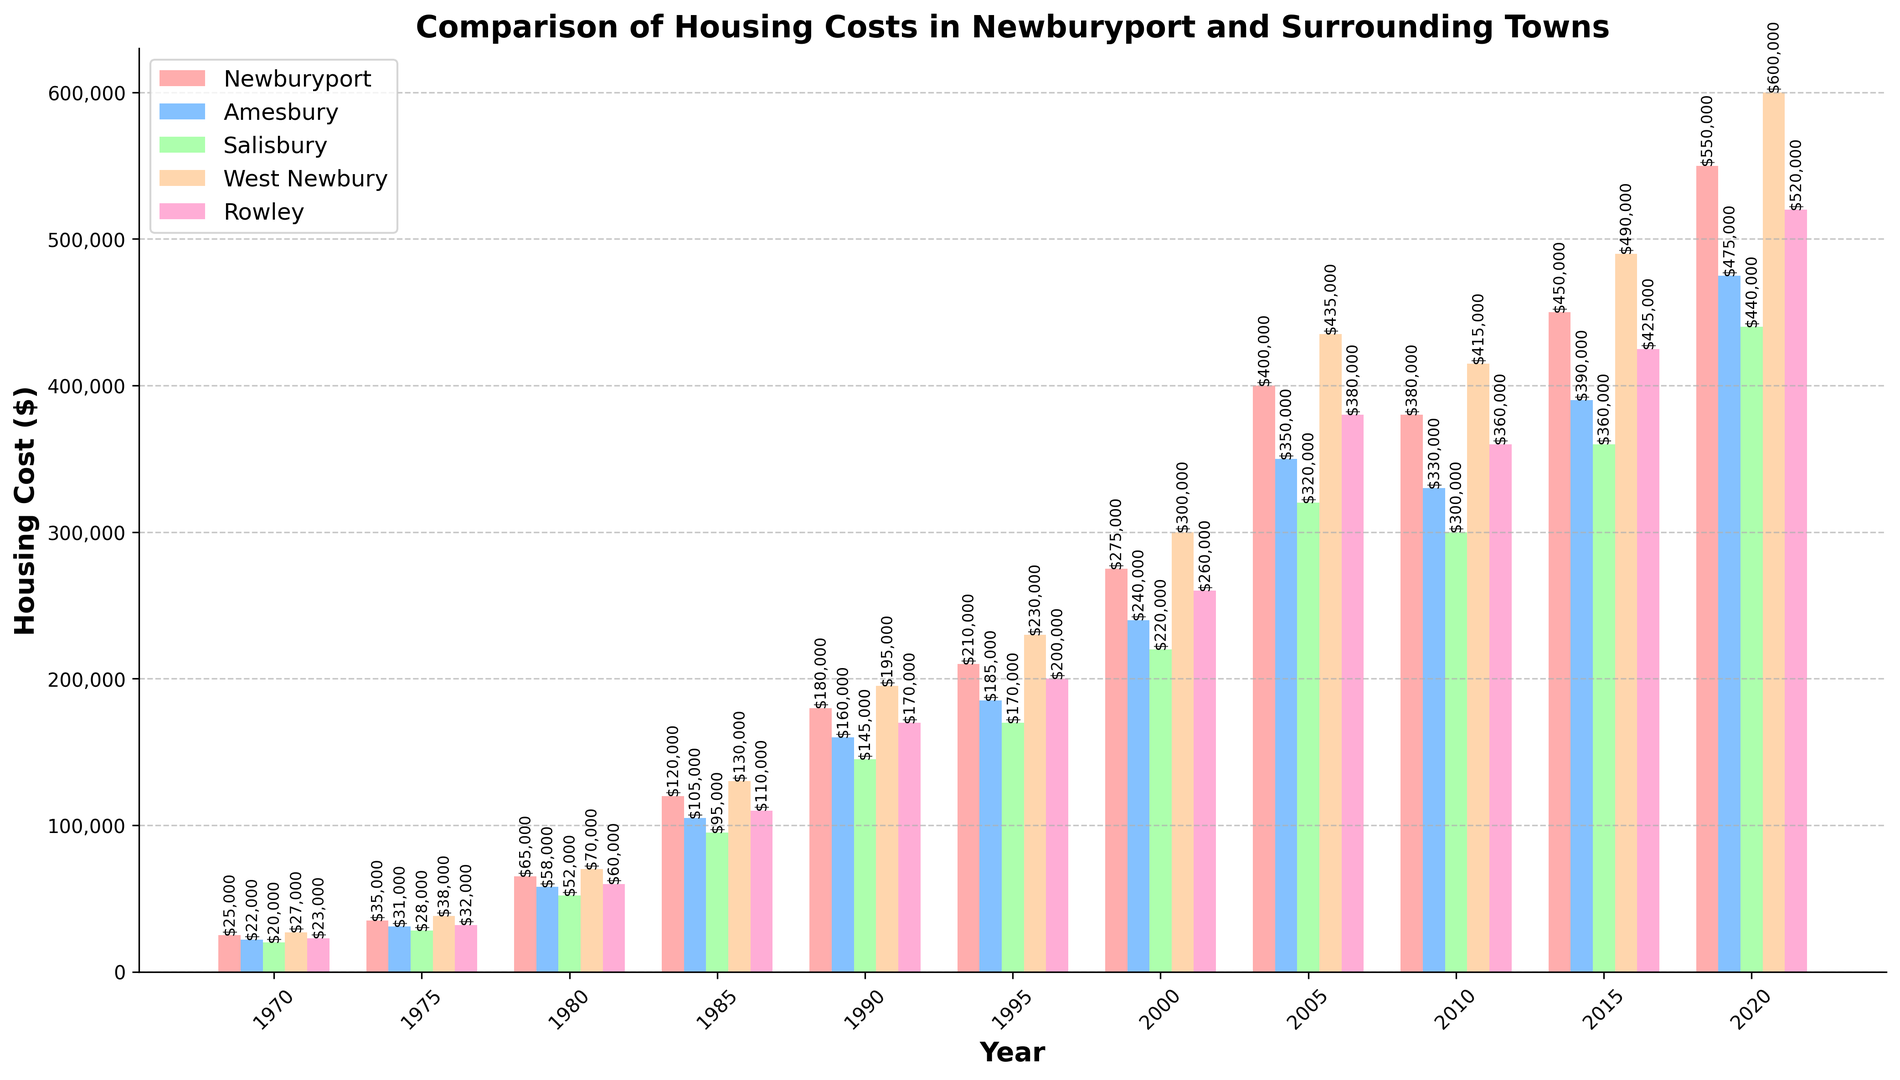What is the trend in housing costs in Newburyport from 1970 to 2020? The trend can be observed by looking at the height of the bars representing Newburyport across the years on the x-axis. From 1970 to 2020, the housing costs in Newburyport show an increasing trend, as the height of the bars continuously rises over the years.
Answer: Increasing How did housing costs in West Newbury change from 2005 to 2010? By comparing the height of the bars for West Newbury in 2005 and 2010, we can see that the housing cost in West Newbury decreased from around 435,000 to around 415,000. This indicates a reduction.
Answer: Decreased Which town had the highest housing cost in 2015? To find the highest housing cost in 2015, we compare the heights of the bars for all towns in that year. West Newbury has the tallest bar, indicating it had the highest housing cost.
Answer: West Newbury What is the difference in housing costs between Newburyport and Salisbury in 2020? For difference calculations, we look at the bars for Newburyport and Salisbury in 2020. The height of the bar for Newburyport is 550,000 and for Salisbury is 440,000. The difference is calculated as 550,000 - 440,000 which equals 110,000.
Answer: 110,000 How has the average housing cost across all towns changed from 1970 to 2020? Average housing cost is calculated by summing the housing costs for all towns in both years and dividing by the number of towns. For 1970: (25000 + 22000 + 20000 + 27000 + 23000) / 5 = 23400. For 2020: (550000 + 475000 + 440000 + 600000 + 520000) / 5 = 517000. The average increased from 23400 to 517000.
Answer: Increased In which year did Rowley have the lowest housing cost? By scanning the heights of the bars representing Rowley over the years, we find the shortest bar corresponds to the year 1970, showing the lowest housing cost.
Answer: 1970 How much did the housing cost in Amesbury increase from 1980 to 1990? We observe the bars for Amesbury in 1980 and 1990. In 1980, the cost was 58,000 and in 1990 it was 160,000. The increase is calculated as 160,000 - 58,000 = 102,000.
Answer: 102,000 What is the total increase in housing costs in Newburyport from 1970 to 2020? To determine the total increase, we subtract the cost in 1970 from the cost in 2020. For Newburyport: 550,000 (2020) - 25,000 (1970) = 525,000.
Answer: 525,000 Which town had the smallest absolute change in housing costs between 2010 and 2015? By comparing the heights of the bars for each town between 2010 and 2015, we calculate the absolute changes: Newburyport (70,000), Amesbury (60,000), Salisbury (60,000), West Newbury (75,000), Rowley (65,000). Salisbury and Amesbury have the smallest absolute change of 60,000.
Answer: Amesbury and Salisbury 